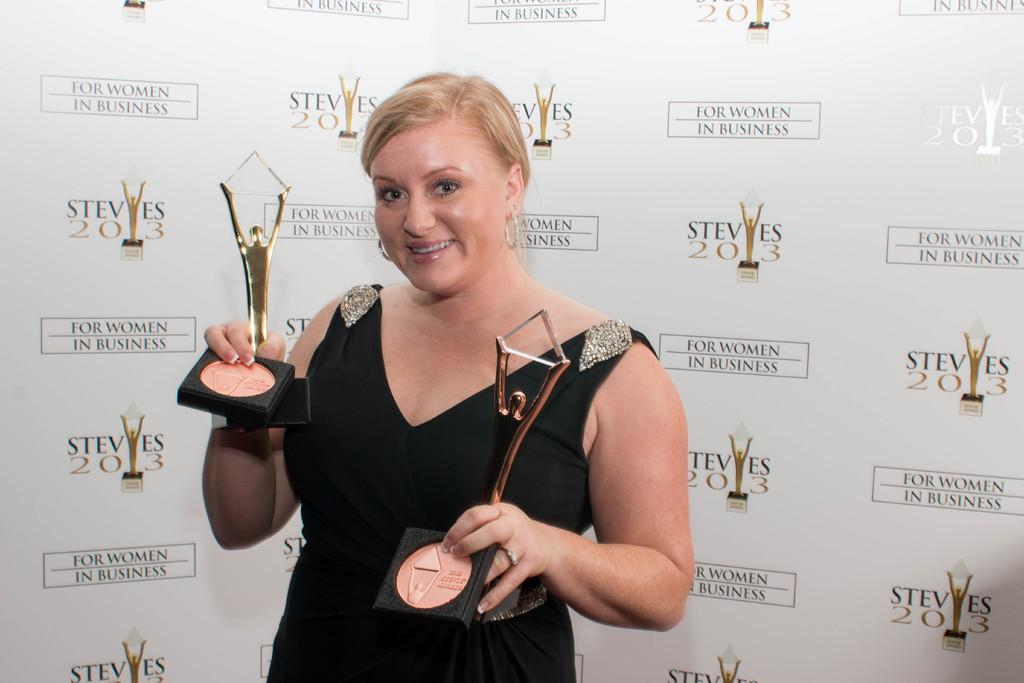Who is the main subject in the image? There is a woman in the image. What is the woman doing in the image? The woman is standing and holding awards in her hands. What is the woman's facial expression in the image? The woman is smiling in the image. What can be seen in the background of the image? There is a poster in the background of the image. How many times does the woman need to fold her arms in the image? The woman is not folding her arms in the image, so the number of times she needs to fold them cannot be determined. 